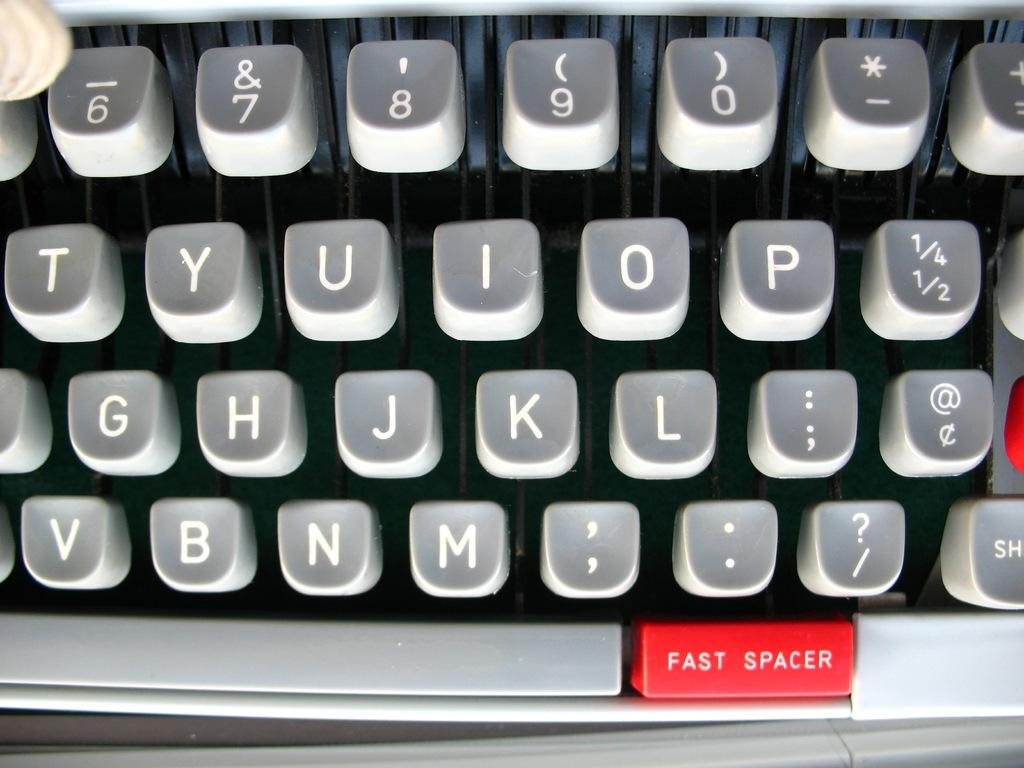Provide a one-sentence caption for the provided image. The keyboard of a type writer is shown with a red button labeled fast spacer at the bottom. 